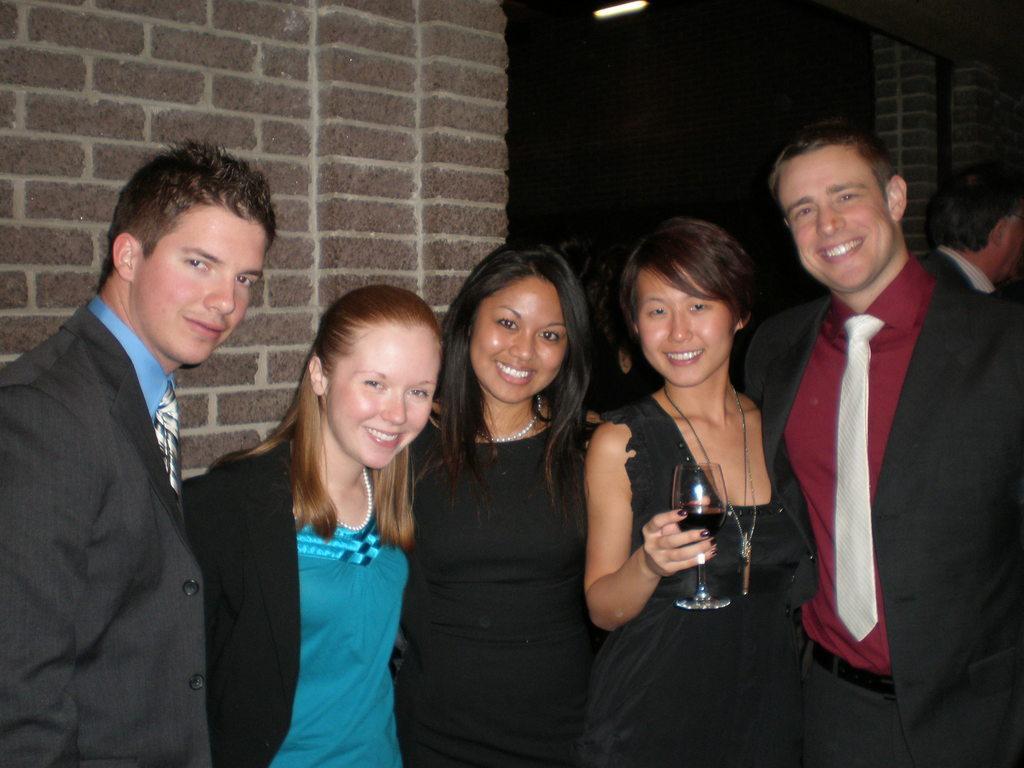Could you give a brief overview of what you see in this image? Here we can see five persons are posing to a camera and they are smiling. She is holding a glass with her hand. In the background we can see wall and light. 